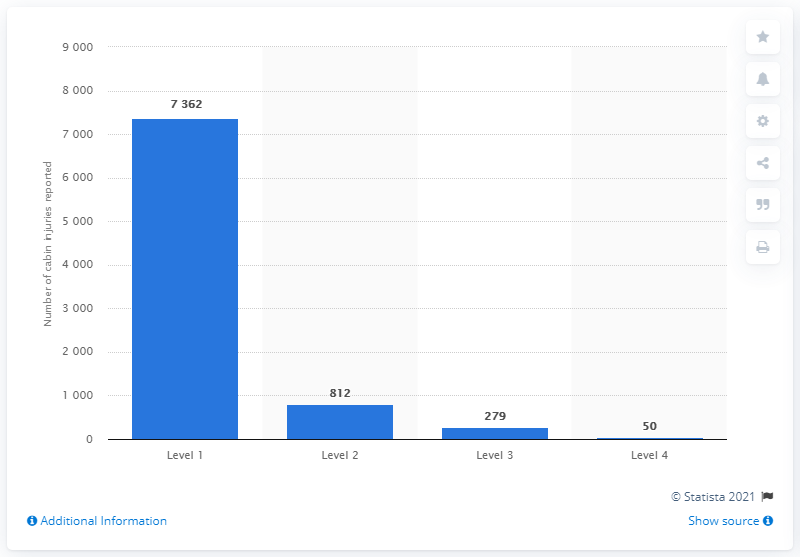List a handful of essential elements in this visual. There were 50 reports of level 4 behavior in 2018. 